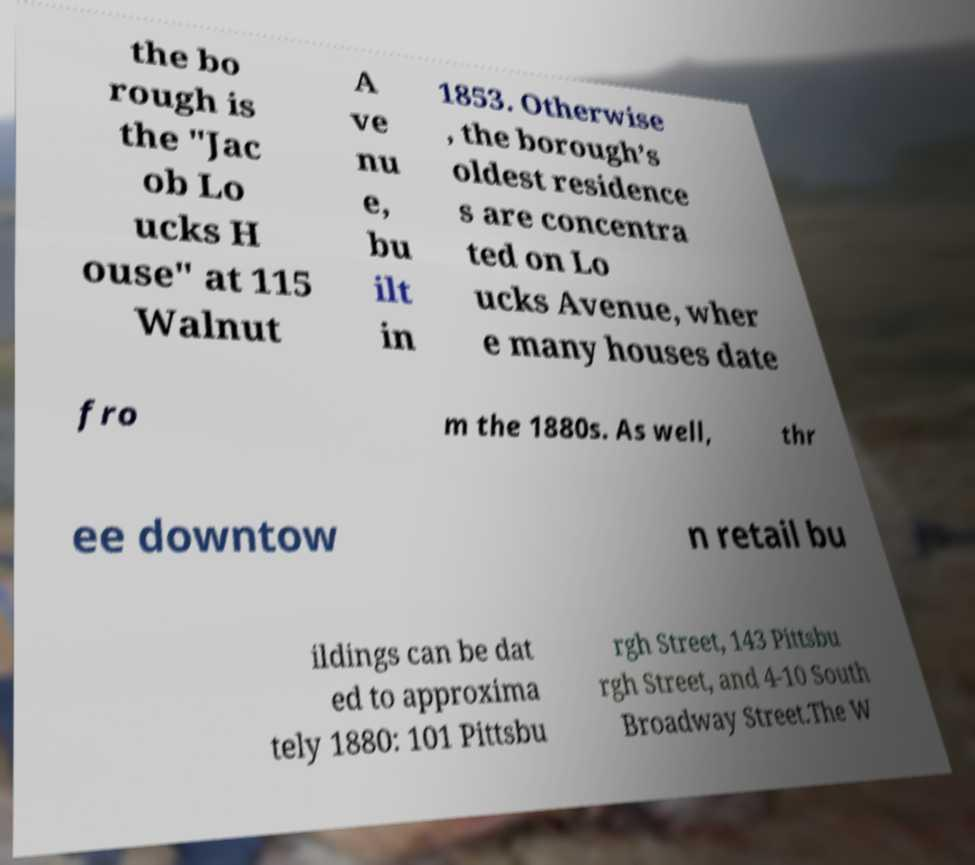Could you extract and type out the text from this image? the bo rough is the "Jac ob Lo ucks H ouse" at 115 Walnut A ve nu e, bu ilt in 1853. Otherwise , the borough’s oldest residence s are concentra ted on Lo ucks Avenue, wher e many houses date fro m the 1880s. As well, thr ee downtow n retail bu ildings can be dat ed to approxima tely 1880: 101 Pittsbu rgh Street, 143 Pittsbu rgh Street, and 4-10 South Broadway Street.The W 